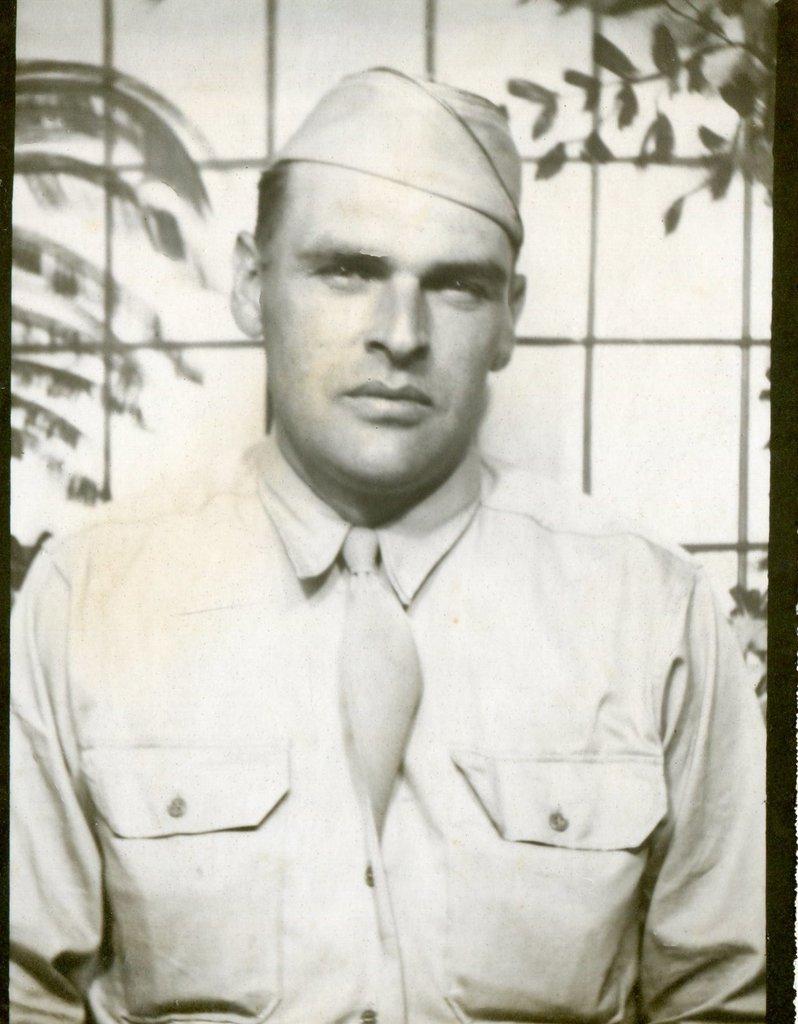Please provide a concise description of this image. In this image we can see a person, there are plants, and the picture is taken in black and white mode. 